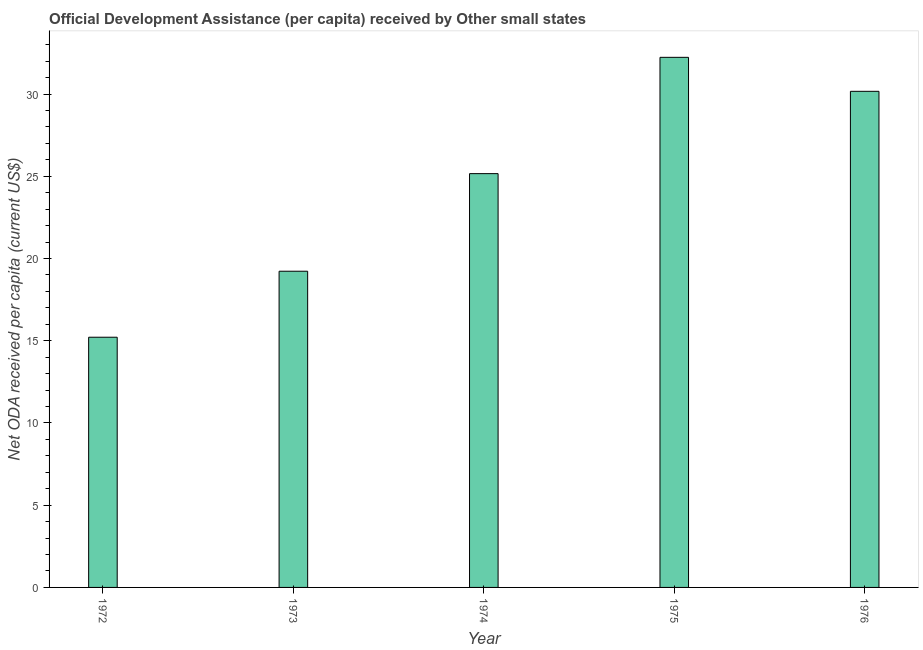Does the graph contain grids?
Offer a very short reply. No. What is the title of the graph?
Give a very brief answer. Official Development Assistance (per capita) received by Other small states. What is the label or title of the X-axis?
Your answer should be compact. Year. What is the label or title of the Y-axis?
Your response must be concise. Net ODA received per capita (current US$). What is the net oda received per capita in 1972?
Offer a very short reply. 15.21. Across all years, what is the maximum net oda received per capita?
Offer a terse response. 32.24. Across all years, what is the minimum net oda received per capita?
Offer a terse response. 15.21. In which year was the net oda received per capita maximum?
Make the answer very short. 1975. In which year was the net oda received per capita minimum?
Your response must be concise. 1972. What is the sum of the net oda received per capita?
Provide a short and direct response. 122.01. What is the difference between the net oda received per capita in 1973 and 1974?
Your answer should be very brief. -5.93. What is the average net oda received per capita per year?
Give a very brief answer. 24.4. What is the median net oda received per capita?
Offer a very short reply. 25.16. What is the ratio of the net oda received per capita in 1972 to that in 1973?
Ensure brevity in your answer.  0.79. What is the difference between the highest and the second highest net oda received per capita?
Make the answer very short. 2.07. What is the difference between the highest and the lowest net oda received per capita?
Provide a succinct answer. 17.02. In how many years, is the net oda received per capita greater than the average net oda received per capita taken over all years?
Provide a succinct answer. 3. How many years are there in the graph?
Give a very brief answer. 5. What is the Net ODA received per capita (current US$) in 1972?
Your response must be concise. 15.21. What is the Net ODA received per capita (current US$) of 1973?
Your answer should be compact. 19.23. What is the Net ODA received per capita (current US$) of 1974?
Offer a terse response. 25.16. What is the Net ODA received per capita (current US$) in 1975?
Ensure brevity in your answer.  32.24. What is the Net ODA received per capita (current US$) of 1976?
Provide a short and direct response. 30.17. What is the difference between the Net ODA received per capita (current US$) in 1972 and 1973?
Your answer should be compact. -4.01. What is the difference between the Net ODA received per capita (current US$) in 1972 and 1974?
Provide a succinct answer. -9.95. What is the difference between the Net ODA received per capita (current US$) in 1972 and 1975?
Make the answer very short. -17.02. What is the difference between the Net ODA received per capita (current US$) in 1972 and 1976?
Offer a terse response. -14.95. What is the difference between the Net ODA received per capita (current US$) in 1973 and 1974?
Keep it short and to the point. -5.94. What is the difference between the Net ODA received per capita (current US$) in 1973 and 1975?
Provide a succinct answer. -13.01. What is the difference between the Net ODA received per capita (current US$) in 1973 and 1976?
Offer a terse response. -10.94. What is the difference between the Net ODA received per capita (current US$) in 1974 and 1975?
Offer a very short reply. -7.07. What is the difference between the Net ODA received per capita (current US$) in 1974 and 1976?
Provide a short and direct response. -5. What is the difference between the Net ODA received per capita (current US$) in 1975 and 1976?
Ensure brevity in your answer.  2.07. What is the ratio of the Net ODA received per capita (current US$) in 1972 to that in 1973?
Your answer should be very brief. 0.79. What is the ratio of the Net ODA received per capita (current US$) in 1972 to that in 1974?
Your answer should be very brief. 0.6. What is the ratio of the Net ODA received per capita (current US$) in 1972 to that in 1975?
Offer a terse response. 0.47. What is the ratio of the Net ODA received per capita (current US$) in 1972 to that in 1976?
Make the answer very short. 0.5. What is the ratio of the Net ODA received per capita (current US$) in 1973 to that in 1974?
Your answer should be very brief. 0.76. What is the ratio of the Net ODA received per capita (current US$) in 1973 to that in 1975?
Make the answer very short. 0.6. What is the ratio of the Net ODA received per capita (current US$) in 1973 to that in 1976?
Make the answer very short. 0.64. What is the ratio of the Net ODA received per capita (current US$) in 1974 to that in 1975?
Offer a terse response. 0.78. What is the ratio of the Net ODA received per capita (current US$) in 1974 to that in 1976?
Offer a terse response. 0.83. What is the ratio of the Net ODA received per capita (current US$) in 1975 to that in 1976?
Offer a very short reply. 1.07. 